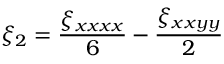<formula> <loc_0><loc_0><loc_500><loc_500>\xi _ { 2 } = \frac { \xi _ { x x x x } } { 6 } - \frac { \xi _ { x x y y } } { 2 }</formula> 